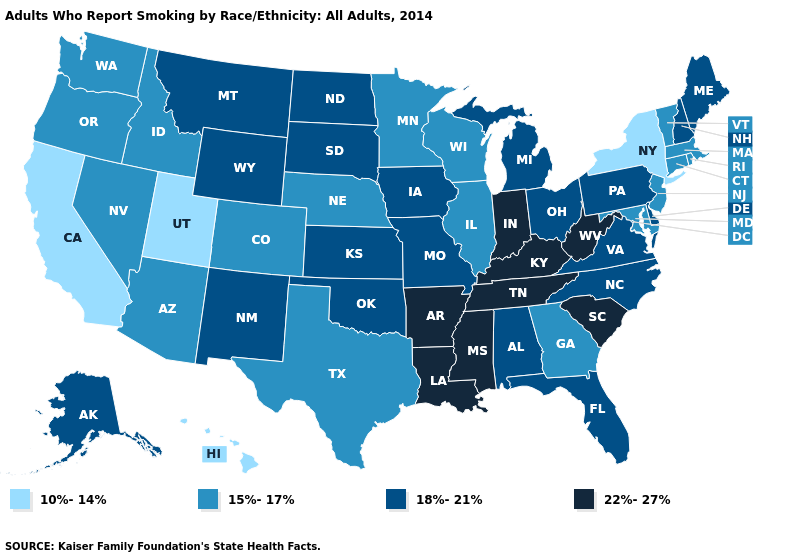What is the lowest value in the West?
Short answer required. 10%-14%. Does the first symbol in the legend represent the smallest category?
Keep it brief. Yes. Among the states that border West Virginia , which have the highest value?
Write a very short answer. Kentucky. What is the highest value in states that border Missouri?
Answer briefly. 22%-27%. What is the value of Nevada?
Be succinct. 15%-17%. Does West Virginia have the highest value in the South?
Short answer required. Yes. What is the value of California?
Concise answer only. 10%-14%. Which states hav the highest value in the Northeast?
Quick response, please. Maine, New Hampshire, Pennsylvania. Does Oregon have a lower value than Nebraska?
Write a very short answer. No. Name the states that have a value in the range 22%-27%?
Write a very short answer. Arkansas, Indiana, Kentucky, Louisiana, Mississippi, South Carolina, Tennessee, West Virginia. Which states hav the highest value in the MidWest?
Keep it brief. Indiana. Among the states that border Minnesota , does Iowa have the lowest value?
Write a very short answer. No. Does Utah have the lowest value in the West?
Keep it brief. Yes. Name the states that have a value in the range 18%-21%?
Keep it brief. Alabama, Alaska, Delaware, Florida, Iowa, Kansas, Maine, Michigan, Missouri, Montana, New Hampshire, New Mexico, North Carolina, North Dakota, Ohio, Oklahoma, Pennsylvania, South Dakota, Virginia, Wyoming. Among the states that border Maryland , does West Virginia have the lowest value?
Concise answer only. No. 